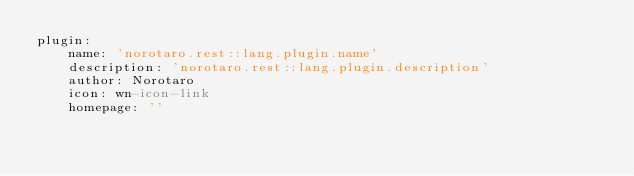<code> <loc_0><loc_0><loc_500><loc_500><_YAML_>plugin:
    name: 'norotaro.rest::lang.plugin.name'
    description: 'norotaro.rest::lang.plugin.description'
    author: Norotaro
    icon: wn-icon-link
    homepage: ''
</code> 